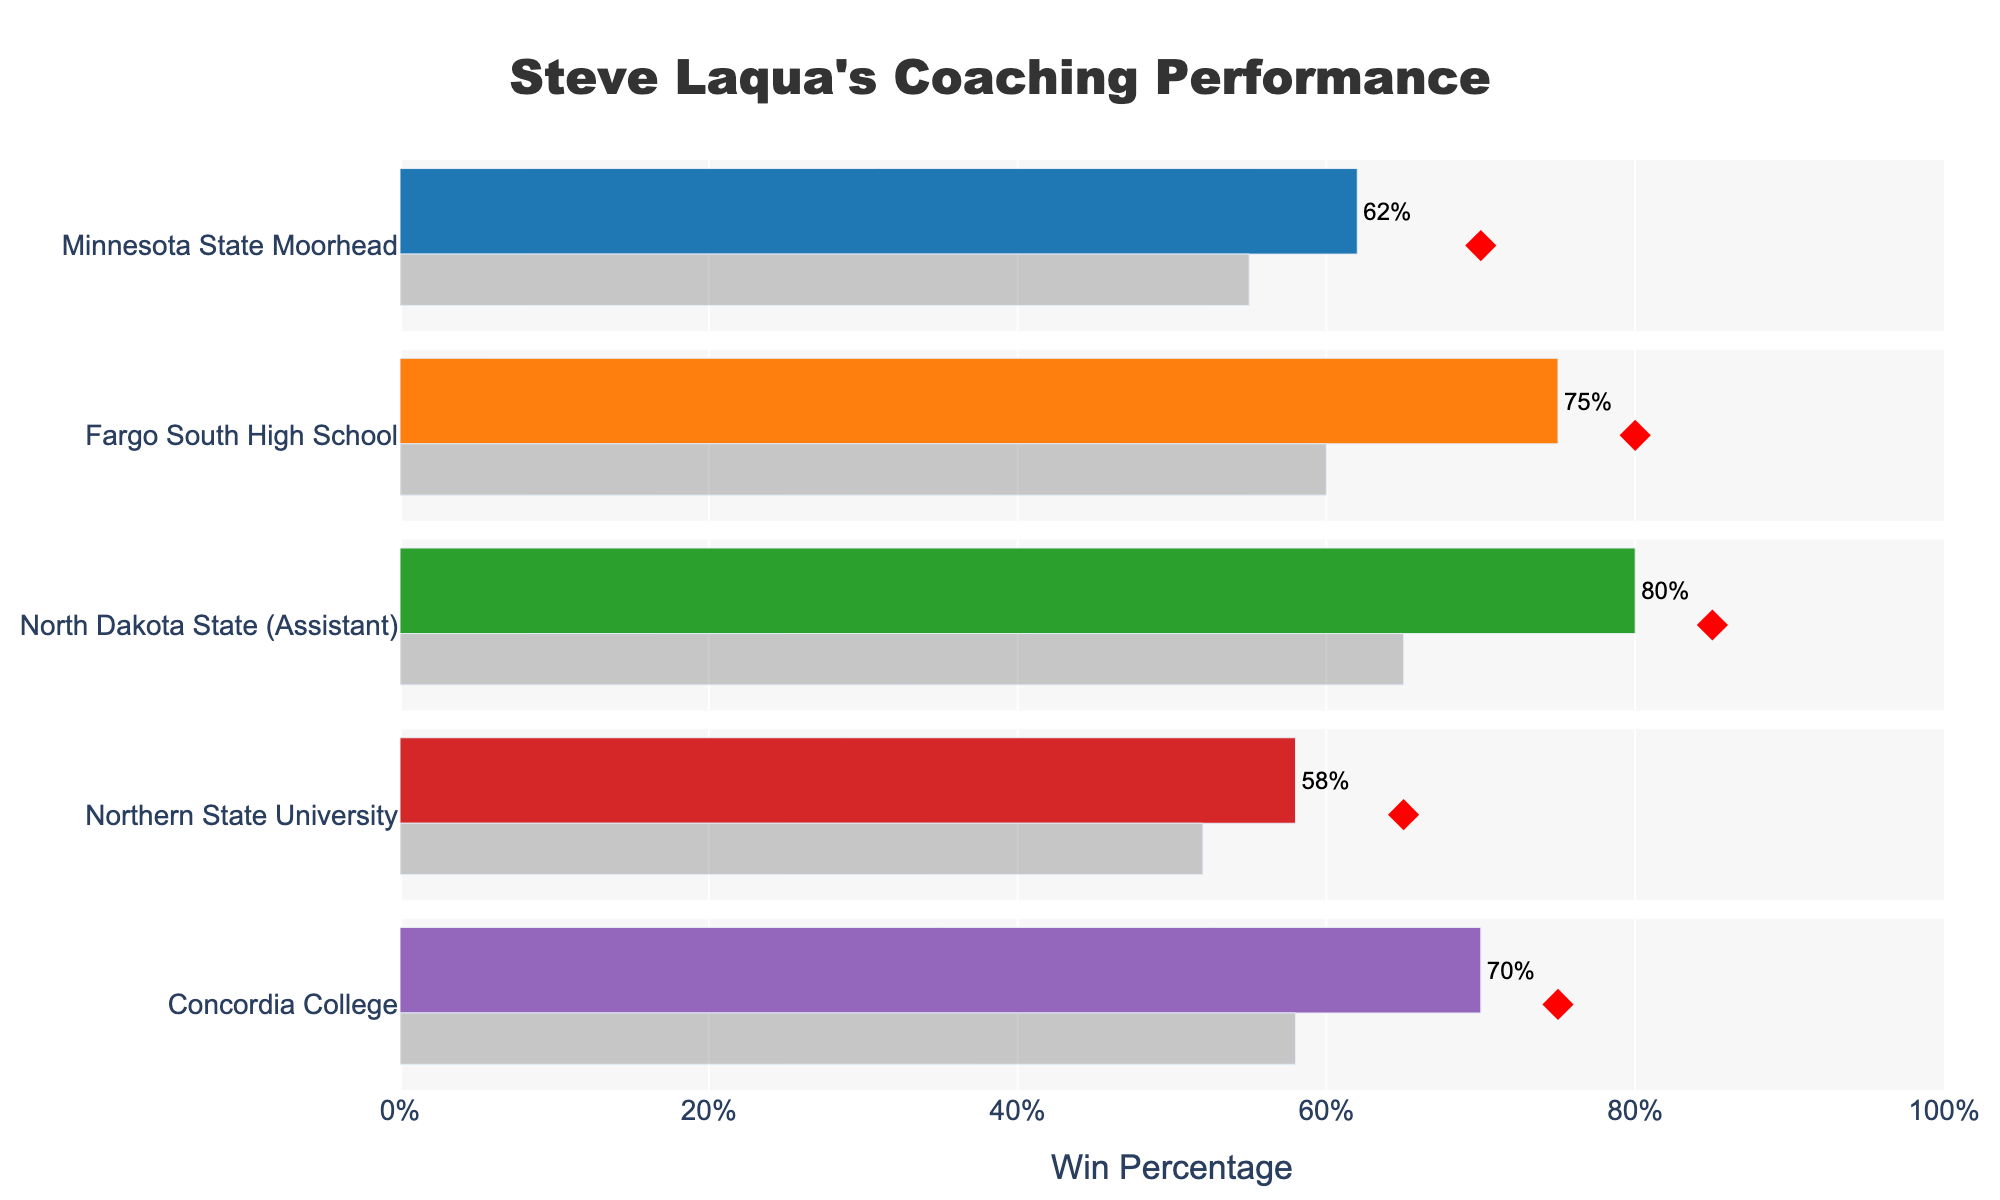What is the title of the chart? The title is displayed at the top of the chart, which is "Steve Laqua's Coaching Performance."
Answer: Steve Laqua's Coaching Performance How many teams' data are represented in the chart? The chart shows data for five different teams, each represented by a different color and positioned in separate rows.
Answer: Five What is the win percentage for Fargo South High School? Fargo South High School is the second team listed in the chart, and its win percentage is shown as a bar with a text label indicating 75%.
Answer: 75% Which team has the highest win percentage? By comparing the heights of the bars representing win percentages for all teams, the team with the highest bar is North Dakota State (Assistant), listed as having an 80% win percentage.
Answer: North Dakota State (Assistant) What is the difference between North Dakota State (Assistant) win percentage and the League Average? The win percentage for North Dakota State (Assistant) is 80%, and the League Average is 65%, so the difference is 80% - 65% = 15%.
Answer: 15% Did Minnesota State Moorhead achieve its target win percentage? Minnesota State Moorhead, the first team in the chart, has a target win percentage indicated by a red diamond at 70%. Its current win percentage is shown as 62%, which is lower than the target.
Answer: No What trend can be observed regarding Steve Laqua's win percentages as it relates to the League Average? By observing the win percentages and League Averages side by side for each team, it can be noted that Steve Laqua's coached teams generally have win percentages either above or very close to the League Average, except for Northern State University and Minnesota State Moorhead, where they are slightly below the League Average.
Answer: Generally above Between Concordia College and Northern State University, which team has a lower win percentage, and by how much? Concordia College's win percentage is 70% and Northern State University's is 58%. The difference is 70% - 58% = 12%. Thus, Northern State University has a lower win percentage by 12%.
Answer: Northern State University, 12% Which team has a win percentage closest to its target percentage? By comparing the win percentages and the target markers for each team, we see that Fargo South High School has a win percentage of 75% and a target of 80%, which is a difference of 5%. This is the smallest difference among all teams.
Answer: Fargo South High School What is the win percentage for Concordia College compared to the League Average for that team? Concordia College has a win percentage of 70%, and the League Average for Concordia College is 58%. By comparing these values, we see that Concordia's win percentage is 70% which is above its League Average of 58%.
Answer: Higher 